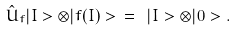<formula> <loc_0><loc_0><loc_500><loc_500>\hat { U } _ { f } | I > \otimes | f ( I ) > \ = \ | I > \otimes | 0 > .</formula> 